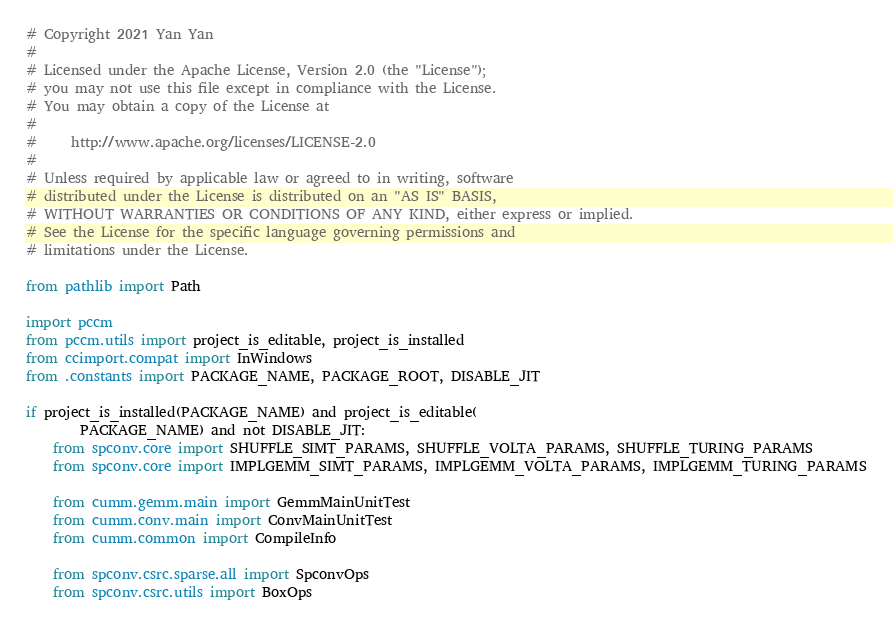Convert code to text. <code><loc_0><loc_0><loc_500><loc_500><_Python_># Copyright 2021 Yan Yan
#
# Licensed under the Apache License, Version 2.0 (the "License");
# you may not use this file except in compliance with the License.
# You may obtain a copy of the License at
#
#     http://www.apache.org/licenses/LICENSE-2.0
#
# Unless required by applicable law or agreed to in writing, software
# distributed under the License is distributed on an "AS IS" BASIS,
# WITHOUT WARRANTIES OR CONDITIONS OF ANY KIND, either express or implied.
# See the License for the specific language governing permissions and
# limitations under the License.

from pathlib import Path

import pccm
from pccm.utils import project_is_editable, project_is_installed
from ccimport.compat import InWindows
from .constants import PACKAGE_NAME, PACKAGE_ROOT, DISABLE_JIT

if project_is_installed(PACKAGE_NAME) and project_is_editable(
        PACKAGE_NAME) and not DISABLE_JIT:
    from spconv.core import SHUFFLE_SIMT_PARAMS, SHUFFLE_VOLTA_PARAMS, SHUFFLE_TURING_PARAMS
    from spconv.core import IMPLGEMM_SIMT_PARAMS, IMPLGEMM_VOLTA_PARAMS, IMPLGEMM_TURING_PARAMS

    from cumm.gemm.main import GemmMainUnitTest
    from cumm.conv.main import ConvMainUnitTest
    from cumm.common import CompileInfo

    from spconv.csrc.sparse.all import SpconvOps
    from spconv.csrc.utils import BoxOps</code> 